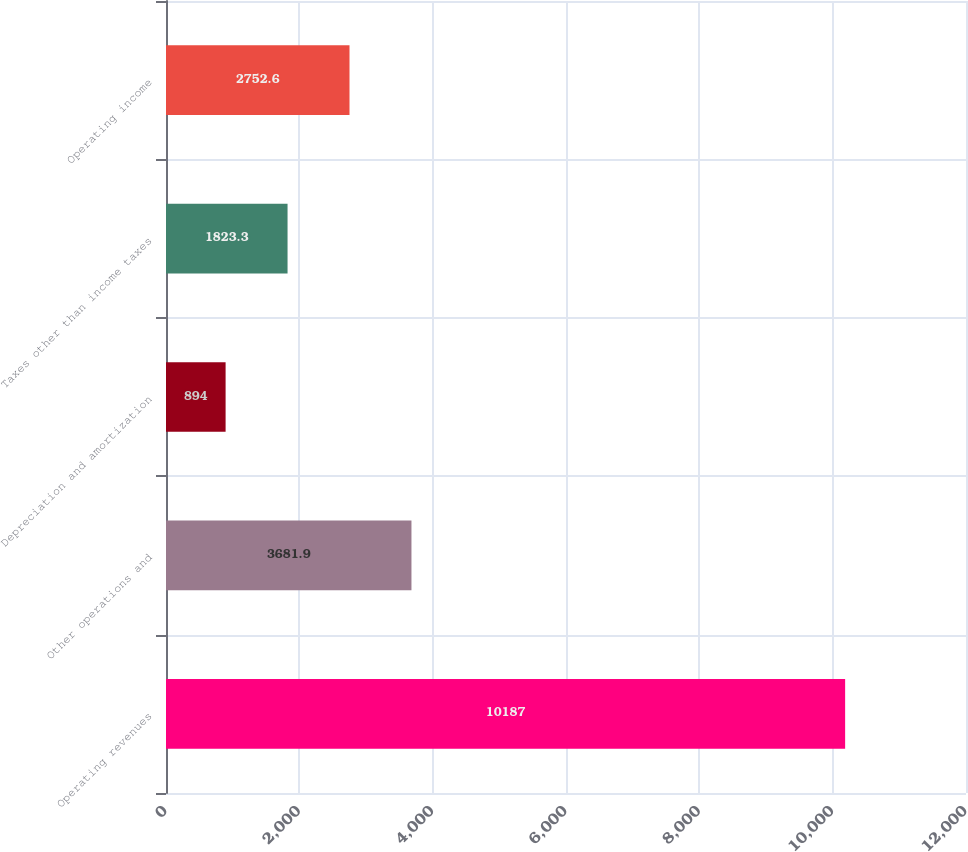Convert chart. <chart><loc_0><loc_0><loc_500><loc_500><bar_chart><fcel>Operating revenues<fcel>Other operations and<fcel>Depreciation and amortization<fcel>Taxes other than income taxes<fcel>Operating income<nl><fcel>10187<fcel>3681.9<fcel>894<fcel>1823.3<fcel>2752.6<nl></chart> 